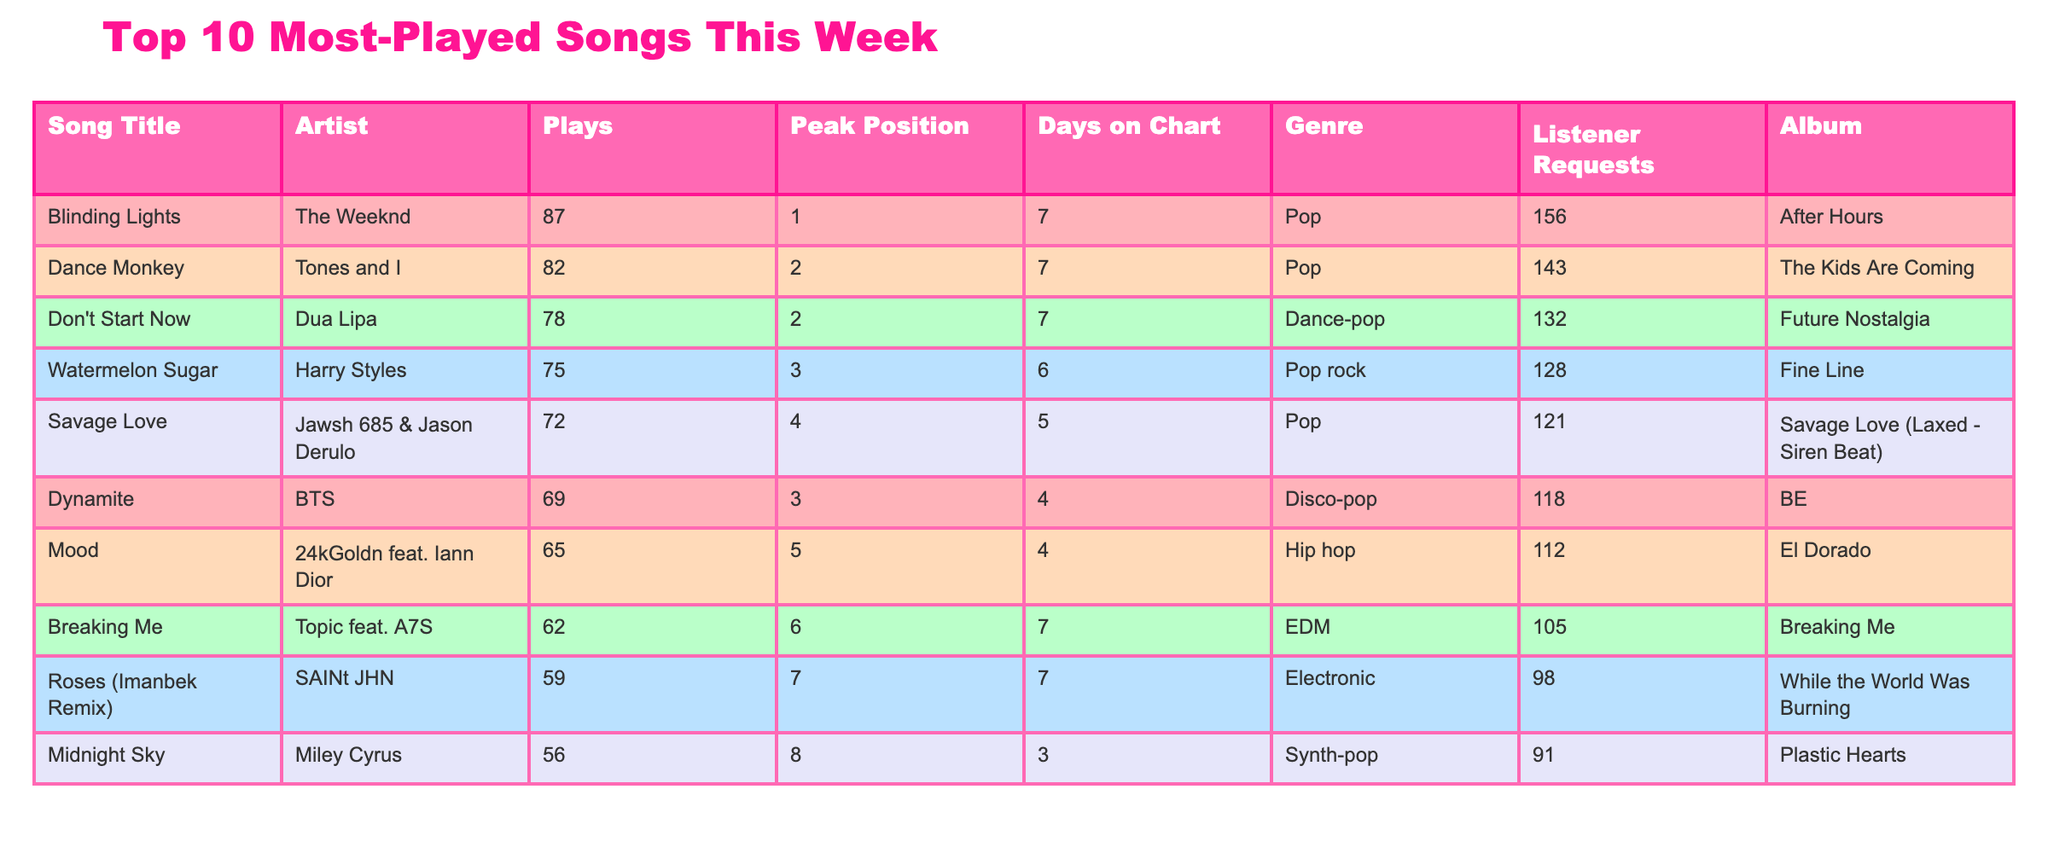What song had the highest number of plays this week? The table lists the number of plays for each song. By inspecting the "Plays" column, "Blinding Lights" has the highest number with 87 plays.
Answer: Blinding Lights Which artist has a song that peaked at position 1? The table includes the "Peak Position" column. Looking through it, "Blinding Lights" by The Weeknd is the only song that peaked at position 1.
Answer: The Weeknd How many plays did the song "Watermelon Sugar" receive? The table shows "Watermelon Sugar" in the "Song Title" column with its corresponding plays in the "Plays" column, which is 75.
Answer: 75 What is the average number of plays for the top 10 songs? To find the average, sum up the plays (87 + 82 + 78 + 75 + 72 + 69 + 65 + 62 + 59 + 56) = 760, then divide by 10, giving an average of 76.
Answer: 76 Is "Dynamite" by BTS among the top 10 most played songs this week? "Dynamite" is present in the table, confirming its place among the top 10 songs.
Answer: Yes What genre does the song "Don't Start Now" belong to? The genre is indicated in the "Genre" column next to the song title. "Don't Start Now" is categorized as "Dance-pop."
Answer: Dance-pop Which song has the least number of listener requests? By reviewing the "Listener Requests" column, "Roses (Imanbek Remix)" has the least requests at 98.
Answer: Roses (Imanbek Remix) Did more people request "Savage Love" or "Dynamite"? Comparing the "Listener Requests," "Savage Love" (121 requests) received more than "Dynamite" (118 requests).
Answer: Savage Love How many songs reached a peak position of 3 or higher? Count the songs listed under "Peak Position" that are 3 or higher; Blinding Lights, Dance Monkey, Watermelon Sugar, and Dynamite contribute to a total of 5 songs.
Answer: 5 What is the peak position of "Midnight Sky"? The "Peak Position" column shows that "Midnight Sky" reached position 8.
Answer: 8 